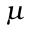Convert formula to latex. <formula><loc_0><loc_0><loc_500><loc_500>\mu</formula> 